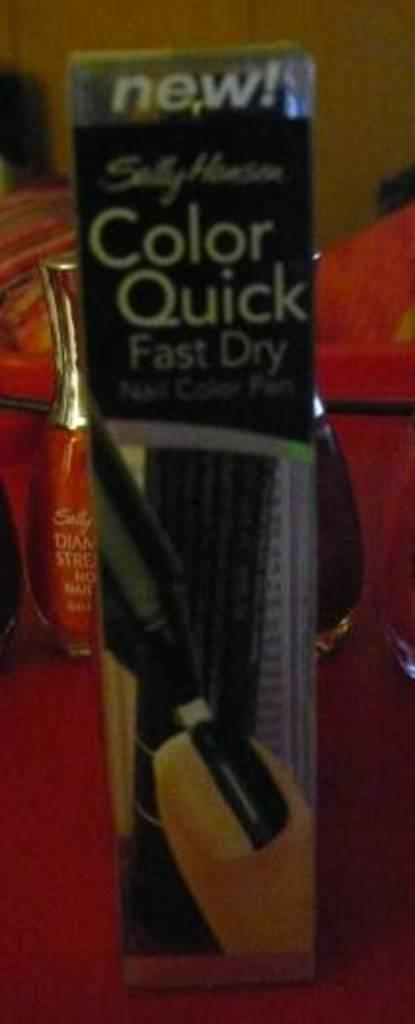Provide a one-sentence caption for the provided image. A red bottle of nail polish is hidden behind a new product that claims to be color quick and fast dry. 